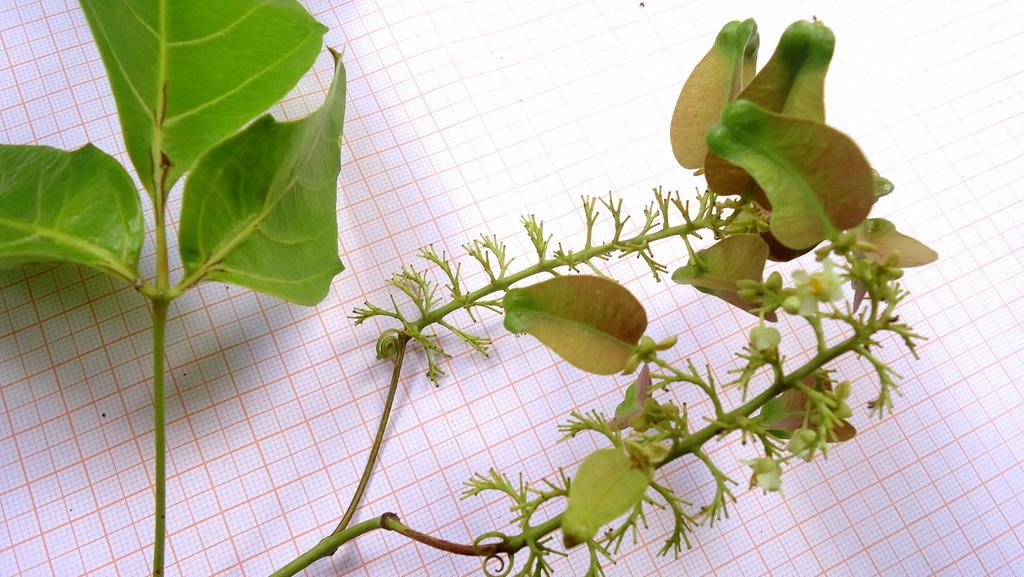What is the main object in the image? The main object in the image is a stem. Where is the stem placed? The stem is placed on a paper. What features can be observed on the stem? The stem has leaves and flowers. How many boys are holding the stem in the image? There are no boys present in the image; it only features a stem with leaves and flowers placed on a paper. 